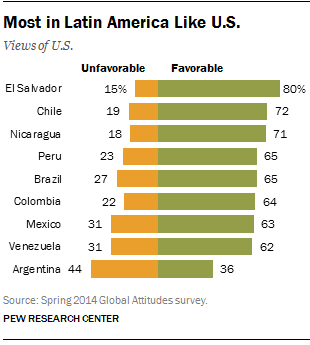Specify some key components in this picture. Argentina has the highest unfavorable rate among countries. There are three countries with favorable ratings over 70. 